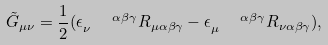Convert formula to latex. <formula><loc_0><loc_0><loc_500><loc_500>\tilde { G } _ { \mu \nu } = \frac { 1 } { 2 } ( \epsilon _ { \nu } ^ { \quad \alpha \beta \gamma } R _ { \mu \alpha \beta \gamma } - \epsilon _ { \mu } ^ { \quad \alpha \beta \gamma } R _ { \nu \alpha \beta \gamma } ) ,</formula> 